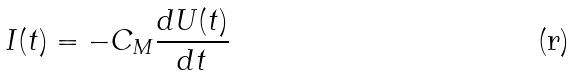Convert formula to latex. <formula><loc_0><loc_0><loc_500><loc_500>I ( t ) = - C _ { M } \frac { d U ( t ) } { d t }</formula> 